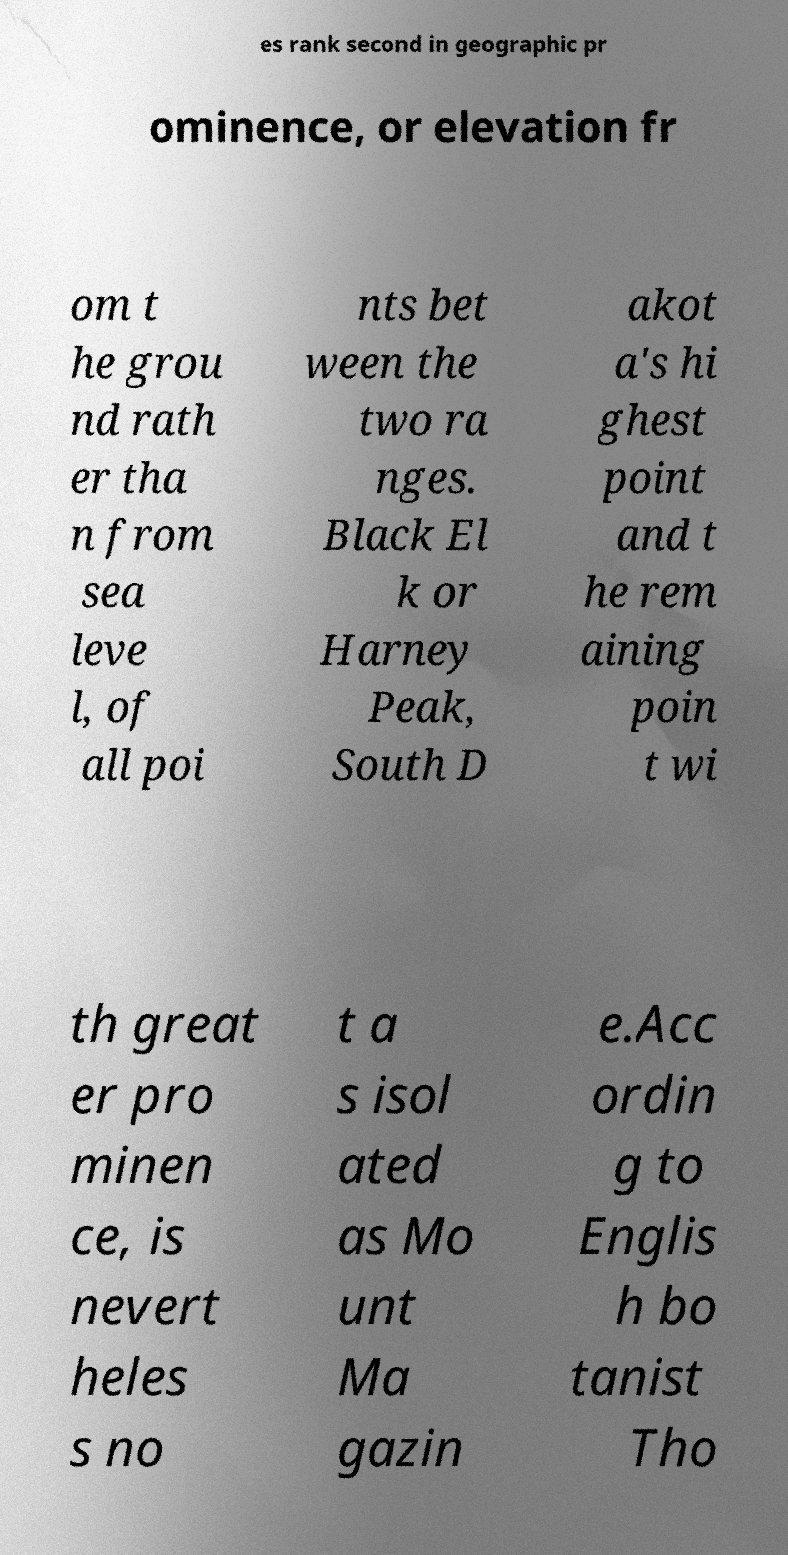There's text embedded in this image that I need extracted. Can you transcribe it verbatim? es rank second in geographic pr ominence, or elevation fr om t he grou nd rath er tha n from sea leve l, of all poi nts bet ween the two ra nges. Black El k or Harney Peak, South D akot a's hi ghest point and t he rem aining poin t wi th great er pro minen ce, is nevert heles s no t a s isol ated as Mo unt Ma gazin e.Acc ordin g to Englis h bo tanist Tho 